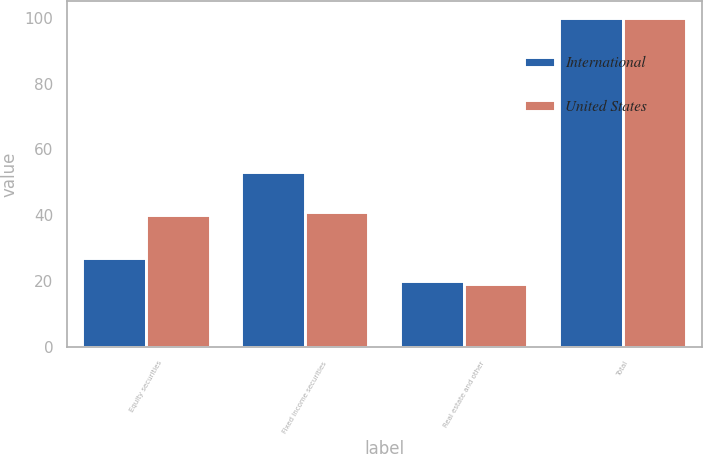Convert chart. <chart><loc_0><loc_0><loc_500><loc_500><stacked_bar_chart><ecel><fcel>Equity securities<fcel>Fixed income securities<fcel>Real estate and other<fcel>Total<nl><fcel>International<fcel>27<fcel>53<fcel>20<fcel>100<nl><fcel>United States<fcel>40<fcel>41<fcel>19<fcel>100<nl></chart> 